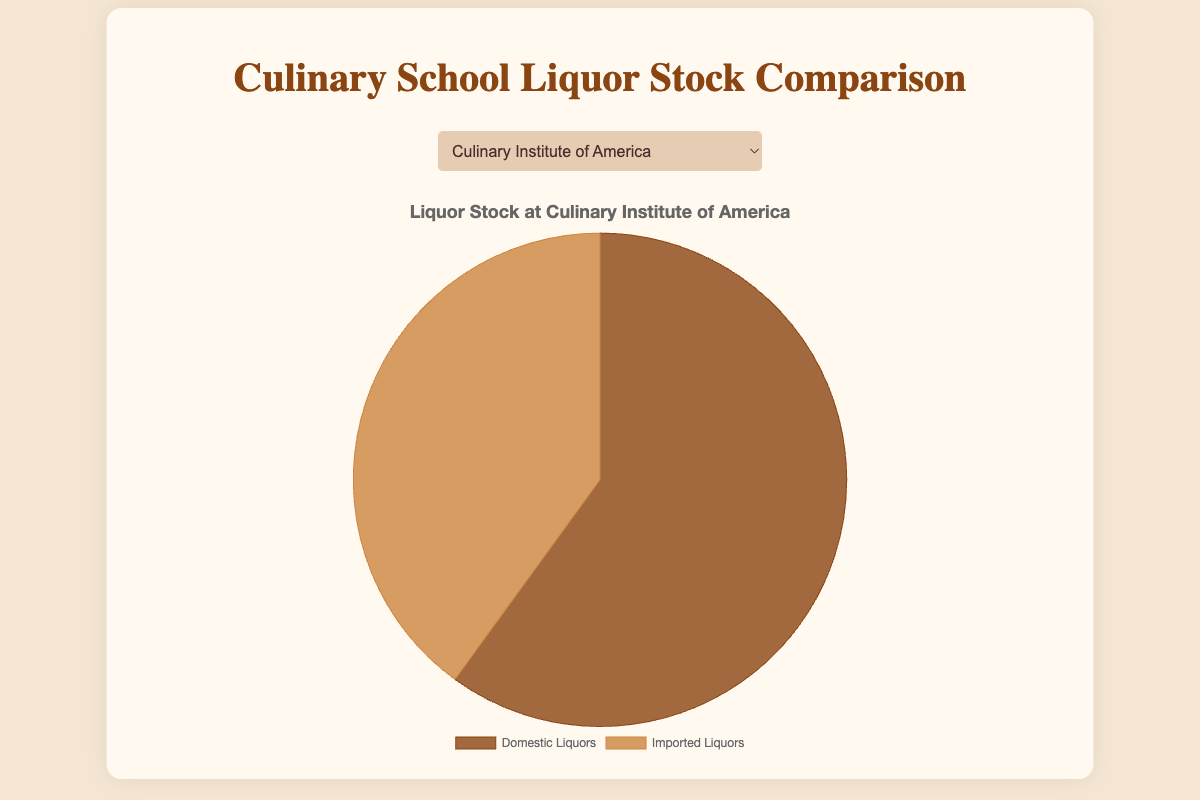Which culinary school stocks the highest proportion of imported liquors? To find which culinary school stocks the highest proportion of imported liquors, refer to the chart for each school and look for the school with the largest slice labeled "Imported Liquors". The "International Culinary Center" has the largest proportion.
Answer: International Culinary Center Which culinary school stocks more domestic liquors: Johnson & Wales University or Le Cordon Bleu College of Culinary Arts? Compare the pie chart slices labeled "Domestic Liquors" for both schools. Johnson & Wales University stocks 35 domestic liquors while Le Cordon Bleu stocks 25 domestic liquors. Johnson & Wales University stocks more.
Answer: Johnson & Wales University What is the difference in the number of domestic liquors between Culinary Institute of America and Institute of Culinary Education? Retrieve the value of domestic liquors from both schools' charts and calculate the difference. Culinary Institute of America has 45 domestic liquors, and Institute of Culinary Education has 40, so the difference is 45 - 40 = 5.
Answer: 5 Which school has the smallest proportion of domestic liquors? Observe each pie chart and identify the school with the smallest slice labeled "Domestic Liquors". The "International Culinary Center" has the smallest proportion with 20 domestic liquors.
Answer: International Culinary Center What is the average number of imported liquors stocked by all the culinary schools? Sum the number of imported liquors across all schools and divide by the number of schools: (30 + 55 + 25 + 60 + 35) / 5 = 205 / 5 = 41.
Answer: 41 Which school has a more balanced stock of domestic and imported liquors: Culinary Institute of America or Institute of Culinary Education? Compare the difference between the slices of domestic and imported liquors for both schools. Culinary Institute of America has 45 domestic and 30 imported (difference of 15), while Institute of Culinary Education has 40 domestic and 35 imported (difference of 5). Institute of Culinary Education has a more balanced stock.
Answer: Institute of Culinary Education 